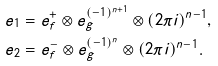Convert formula to latex. <formula><loc_0><loc_0><loc_500><loc_500>e _ { 1 } & = e _ { f } ^ { + } \otimes e _ { g } ^ { ( - 1 ) ^ { n + 1 } } \otimes ( 2 \pi i ) ^ { n - 1 } , \\ e _ { 2 } & = e _ { f } ^ { - } \otimes e _ { g } ^ { ( - 1 ) ^ { n } } \otimes ( 2 \pi i ) ^ { n - 1 } .</formula> 